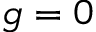<formula> <loc_0><loc_0><loc_500><loc_500>g = 0</formula> 